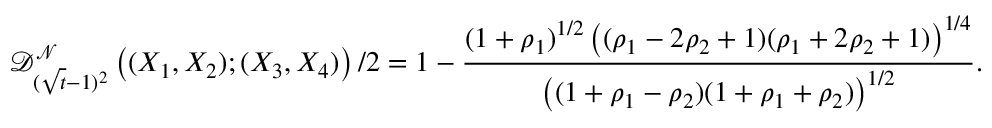<formula> <loc_0><loc_0><loc_500><loc_500>\mathcal { D } _ { ( \sqrt { t } - 1 ) ^ { 2 } } ^ { \mathcal { N } } \left ( ( X _ { 1 } , X _ { 2 } ) ; ( X _ { 3 } , X _ { 4 } ) \right ) / 2 = 1 - \frac { ( 1 + \rho _ { 1 } ) ^ { 1 / 2 } \left ( ( \rho _ { 1 } - 2 \rho _ { 2 } + 1 ) ( \rho _ { 1 } + 2 \rho _ { 2 } + 1 ) \right ) ^ { 1 / 4 } } { \left ( ( 1 + \rho _ { 1 } - \rho _ { 2 } ) ( 1 + \rho _ { 1 } + \rho _ { 2 } ) \right ) ^ { 1 / 2 } } .</formula> 